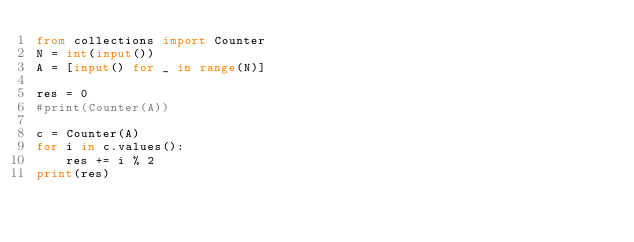<code> <loc_0><loc_0><loc_500><loc_500><_Python_>from collections import Counter
N = int(input())
A = [input() for _ in range(N)]

res = 0
#print(Counter(A))

c = Counter(A)
for i in c.values():
    res += i % 2
print(res)
</code> 